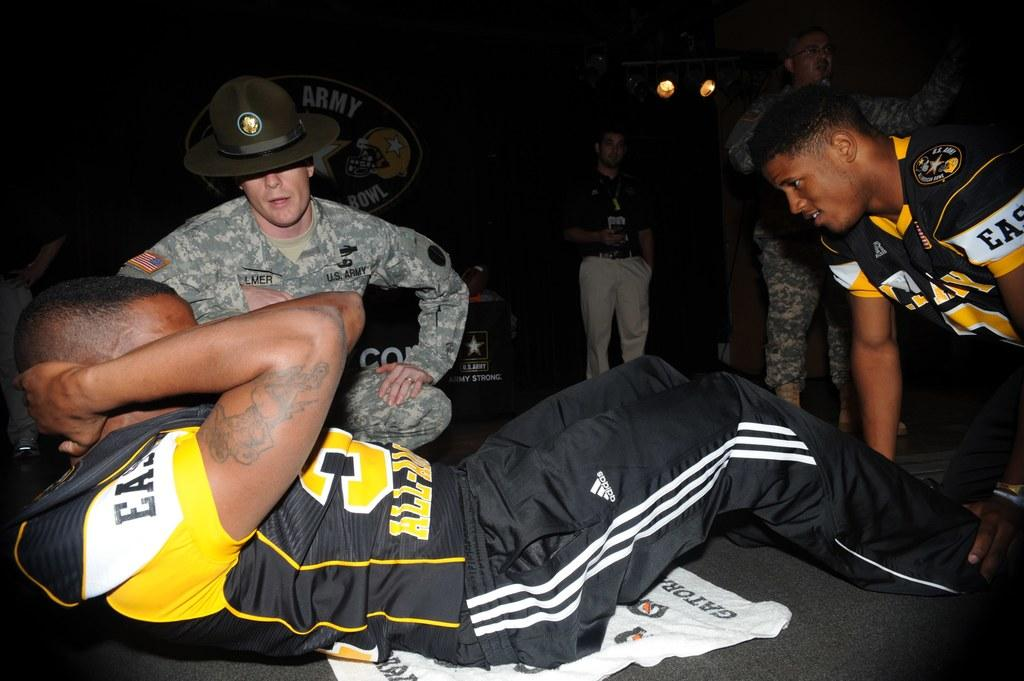<image>
Present a compact description of the photo's key features. the letters EA are on the sleeve of a person 